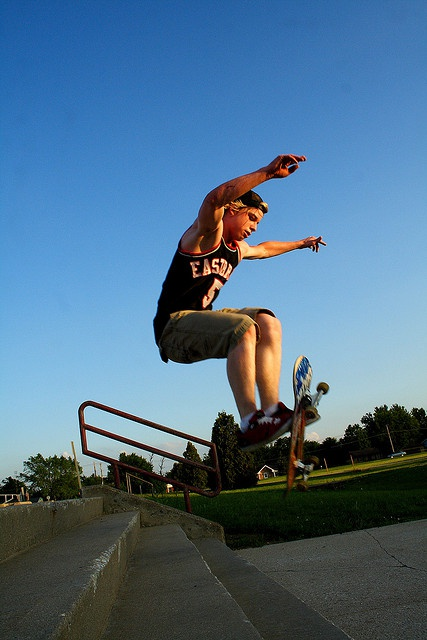Describe the objects in this image and their specific colors. I can see people in blue, black, maroon, orange, and brown tones, skateboard in blue, black, maroon, olive, and gray tones, and car in blue, black, gray, and darkblue tones in this image. 